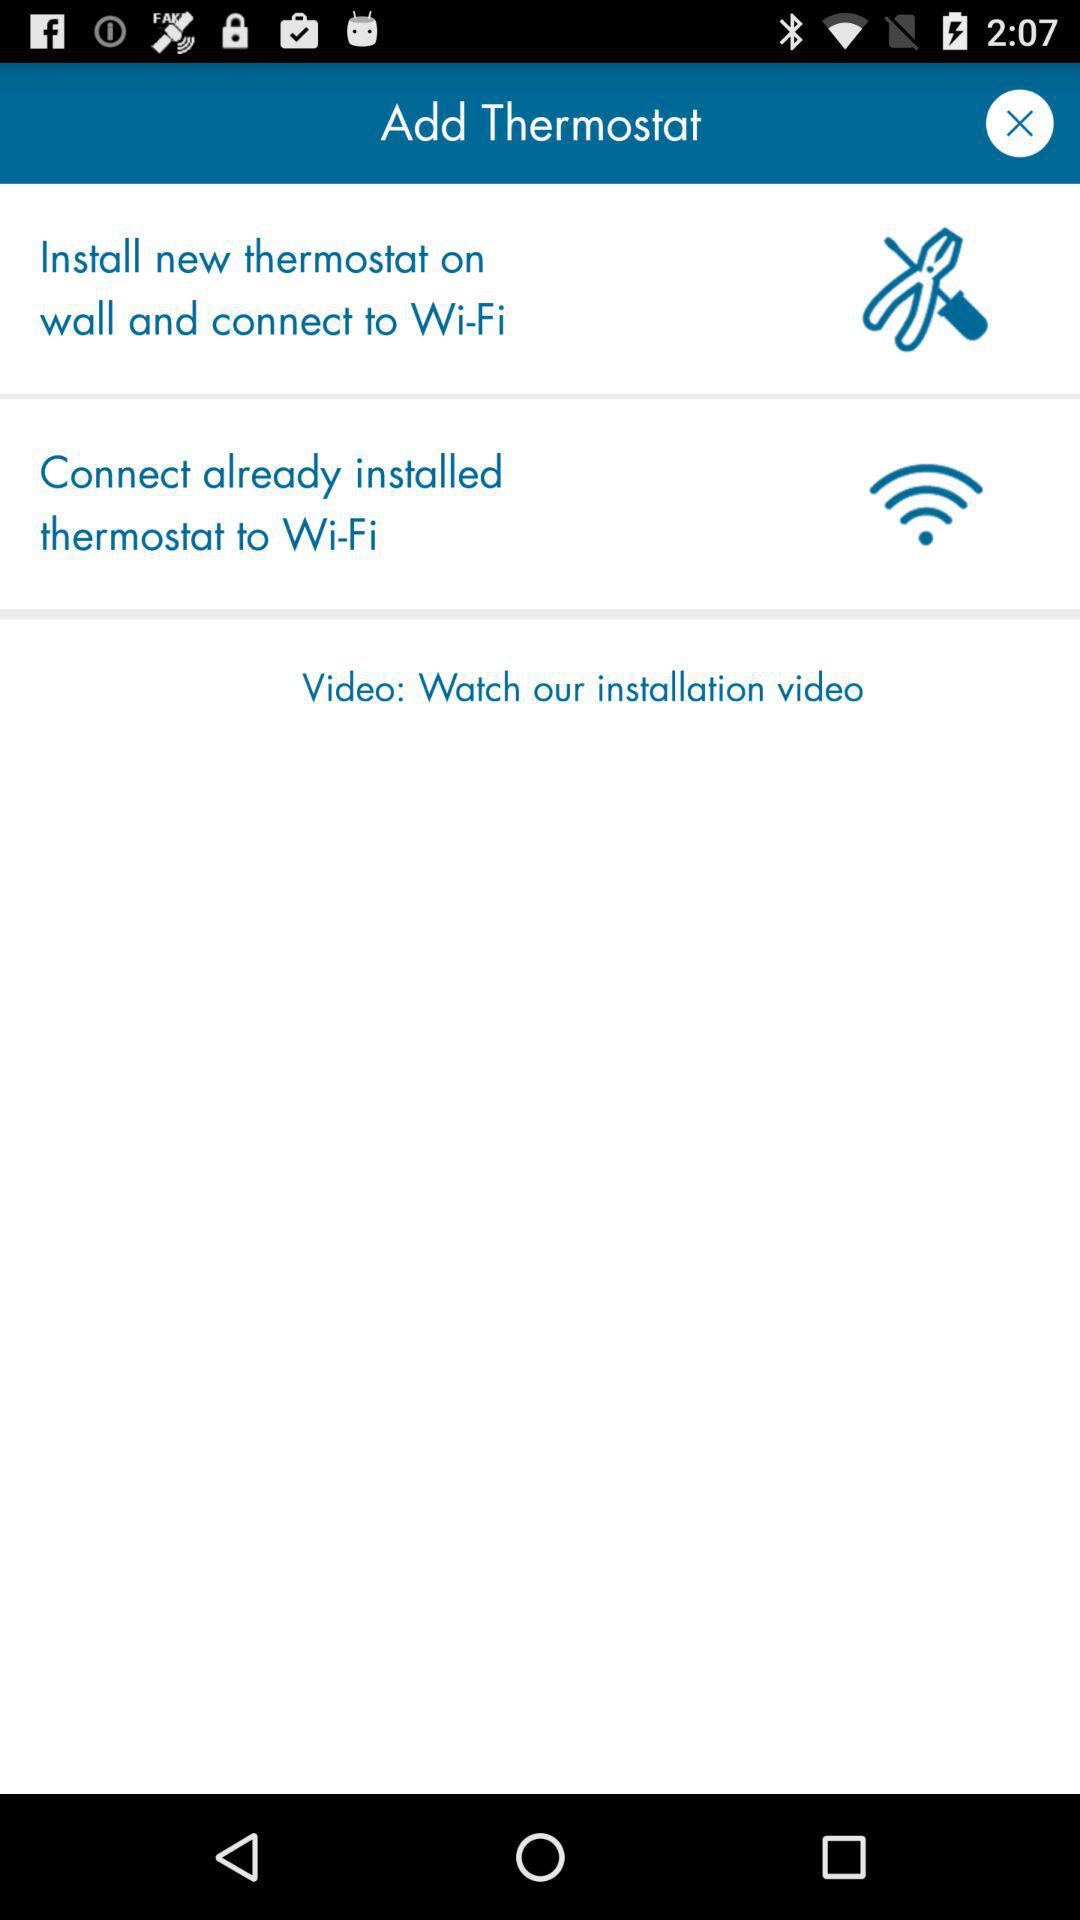How many ways are there to connect a thermostat to Wi-Fi?
Answer the question using a single word or phrase. 2 